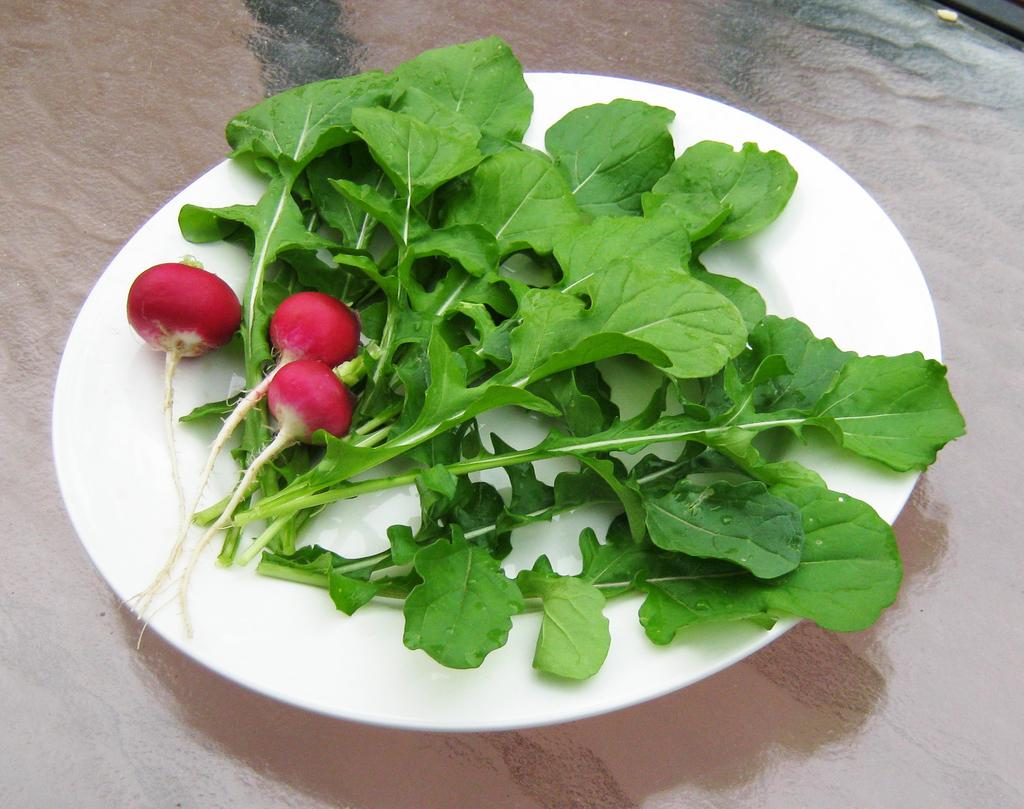What is on the plate that is visible in the image? The plate contains green leafy vegetables. Are there any other items on the plate besides the vegetables? Yes, there are other objects on the plate. Where is the plate located in the image? The plate is on a table. Who is the girl celebrating her birthday in the image? There is no girl or birthday celebration present in the image. 